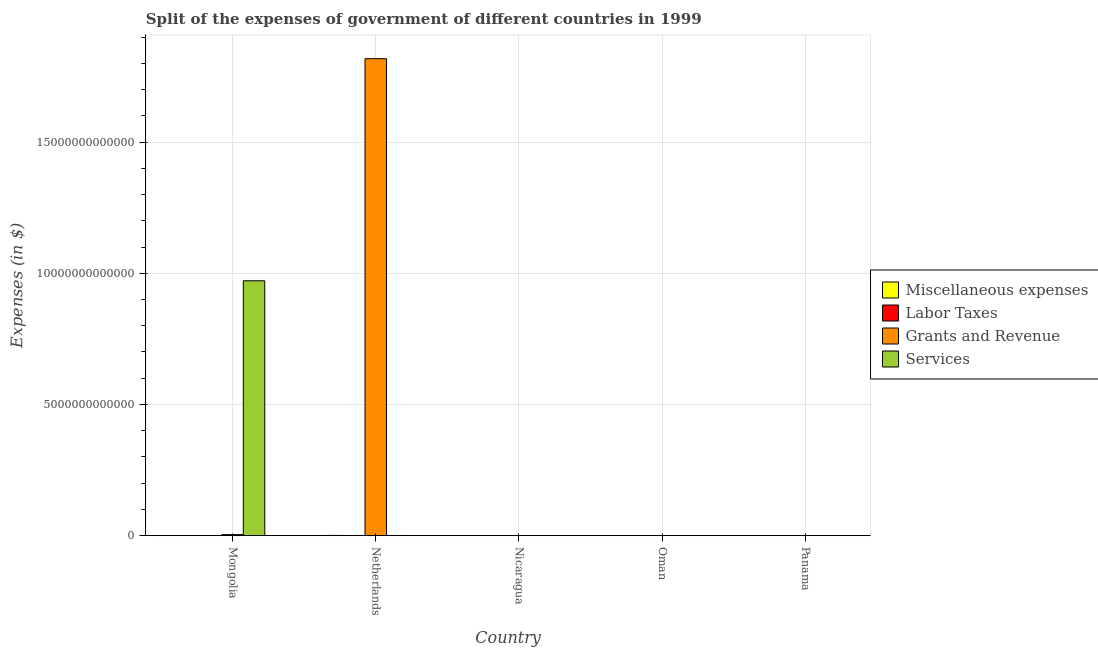How many different coloured bars are there?
Your answer should be compact. 4. How many groups of bars are there?
Provide a short and direct response. 5. Are the number of bars per tick equal to the number of legend labels?
Your response must be concise. No. How many bars are there on the 5th tick from the right?
Give a very brief answer. 4. What is the label of the 5th group of bars from the left?
Provide a short and direct response. Panama. What is the amount spent on grants and revenue in Panama?
Make the answer very short. 5.58e+08. Across all countries, what is the maximum amount spent on services?
Your answer should be compact. 9.71e+12. Across all countries, what is the minimum amount spent on labor taxes?
Ensure brevity in your answer.  0. In which country was the amount spent on labor taxes maximum?
Your answer should be compact. Oman. What is the total amount spent on labor taxes in the graph?
Make the answer very short. 1.25e+09. What is the difference between the amount spent on services in Mongolia and that in Panama?
Ensure brevity in your answer.  9.71e+12. What is the difference between the amount spent on services in Panama and the amount spent on miscellaneous expenses in Mongolia?
Your response must be concise. 3.16e+08. What is the average amount spent on miscellaneous expenses per country?
Provide a succinct answer. 1.67e+09. What is the difference between the amount spent on miscellaneous expenses and amount spent on services in Nicaragua?
Make the answer very short. 1.30e+09. What is the ratio of the amount spent on services in Mongolia to that in Oman?
Offer a very short reply. 2.63e+04. Is the difference between the amount spent on grants and revenue in Mongolia and Netherlands greater than the difference between the amount spent on miscellaneous expenses in Mongolia and Netherlands?
Make the answer very short. No. What is the difference between the highest and the second highest amount spent on labor taxes?
Your response must be concise. 4.94e+08. What is the difference between the highest and the lowest amount spent on grants and revenue?
Make the answer very short. 1.82e+13. Is the sum of the amount spent on services in Oman and Panama greater than the maximum amount spent on grants and revenue across all countries?
Provide a succinct answer. No. Is it the case that in every country, the sum of the amount spent on services and amount spent on miscellaneous expenses is greater than the sum of amount spent on labor taxes and amount spent on grants and revenue?
Make the answer very short. No. Is it the case that in every country, the sum of the amount spent on miscellaneous expenses and amount spent on labor taxes is greater than the amount spent on grants and revenue?
Your answer should be very brief. No. How many bars are there?
Your answer should be compact. 19. Are all the bars in the graph horizontal?
Your answer should be very brief. No. What is the difference between two consecutive major ticks on the Y-axis?
Give a very brief answer. 5.00e+12. Does the graph contain grids?
Offer a very short reply. Yes. Where does the legend appear in the graph?
Ensure brevity in your answer.  Center right. How many legend labels are there?
Offer a very short reply. 4. How are the legend labels stacked?
Offer a very short reply. Vertical. What is the title of the graph?
Provide a short and direct response. Split of the expenses of government of different countries in 1999. Does "Payroll services" appear as one of the legend labels in the graph?
Offer a terse response. No. What is the label or title of the X-axis?
Your answer should be compact. Country. What is the label or title of the Y-axis?
Your response must be concise. Expenses (in $). What is the Expenses (in $) in Miscellaneous expenses in Mongolia?
Your answer should be compact. 2.08e+09. What is the Expenses (in $) in Grants and Revenue in Mongolia?
Your answer should be very brief. 3.67e+1. What is the Expenses (in $) of Services in Mongolia?
Your answer should be compact. 9.71e+12. What is the Expenses (in $) in Miscellaneous expenses in Netherlands?
Offer a terse response. 4.78e+09. What is the Expenses (in $) in Labor Taxes in Netherlands?
Ensure brevity in your answer.  7.00e+05. What is the Expenses (in $) of Grants and Revenue in Netherlands?
Make the answer very short. 1.82e+13. What is the Expenses (in $) in Services in Netherlands?
Provide a succinct answer. 3.37e+09. What is the Expenses (in $) in Miscellaneous expenses in Nicaragua?
Your response must be concise. 1.48e+09. What is the Expenses (in $) of Labor Taxes in Nicaragua?
Your response must be concise. 3.77e+08. What is the Expenses (in $) of Grants and Revenue in Nicaragua?
Provide a short and direct response. 2.05e+09. What is the Expenses (in $) in Services in Nicaragua?
Keep it short and to the point. 1.86e+08. What is the Expenses (in $) of Miscellaneous expenses in Oman?
Keep it short and to the point. 1.80e+06. What is the Expenses (in $) in Labor Taxes in Oman?
Give a very brief answer. 8.71e+08. What is the Expenses (in $) in Grants and Revenue in Oman?
Your answer should be very brief. 1.65e+08. What is the Expenses (in $) of Services in Oman?
Your answer should be very brief. 3.69e+08. What is the Expenses (in $) of Miscellaneous expenses in Panama?
Offer a terse response. 1.29e+07. What is the Expenses (in $) of Grants and Revenue in Panama?
Offer a very short reply. 5.58e+08. What is the Expenses (in $) of Services in Panama?
Your answer should be compact. 2.40e+09. Across all countries, what is the maximum Expenses (in $) of Miscellaneous expenses?
Give a very brief answer. 4.78e+09. Across all countries, what is the maximum Expenses (in $) in Labor Taxes?
Provide a short and direct response. 8.71e+08. Across all countries, what is the maximum Expenses (in $) in Grants and Revenue?
Keep it short and to the point. 1.82e+13. Across all countries, what is the maximum Expenses (in $) in Services?
Your response must be concise. 9.71e+12. Across all countries, what is the minimum Expenses (in $) in Miscellaneous expenses?
Your answer should be very brief. 1.80e+06. Across all countries, what is the minimum Expenses (in $) of Labor Taxes?
Keep it short and to the point. 0. Across all countries, what is the minimum Expenses (in $) in Grants and Revenue?
Give a very brief answer. 1.65e+08. Across all countries, what is the minimum Expenses (in $) of Services?
Your response must be concise. 1.86e+08. What is the total Expenses (in $) in Miscellaneous expenses in the graph?
Offer a terse response. 8.36e+09. What is the total Expenses (in $) of Labor Taxes in the graph?
Your answer should be very brief. 1.25e+09. What is the total Expenses (in $) of Grants and Revenue in the graph?
Your response must be concise. 1.82e+13. What is the total Expenses (in $) of Services in the graph?
Give a very brief answer. 9.72e+12. What is the difference between the Expenses (in $) in Miscellaneous expenses in Mongolia and that in Netherlands?
Offer a very short reply. -2.69e+09. What is the difference between the Expenses (in $) in Labor Taxes in Mongolia and that in Netherlands?
Offer a very short reply. -6.00e+05. What is the difference between the Expenses (in $) in Grants and Revenue in Mongolia and that in Netherlands?
Your response must be concise. -1.81e+13. What is the difference between the Expenses (in $) of Services in Mongolia and that in Netherlands?
Make the answer very short. 9.71e+12. What is the difference between the Expenses (in $) in Miscellaneous expenses in Mongolia and that in Nicaragua?
Keep it short and to the point. 6.04e+08. What is the difference between the Expenses (in $) in Labor Taxes in Mongolia and that in Nicaragua?
Your answer should be very brief. -3.77e+08. What is the difference between the Expenses (in $) in Grants and Revenue in Mongolia and that in Nicaragua?
Your answer should be very brief. 3.46e+1. What is the difference between the Expenses (in $) of Services in Mongolia and that in Nicaragua?
Offer a terse response. 9.71e+12. What is the difference between the Expenses (in $) in Miscellaneous expenses in Mongolia and that in Oman?
Provide a succinct answer. 2.08e+09. What is the difference between the Expenses (in $) of Labor Taxes in Mongolia and that in Oman?
Provide a short and direct response. -8.71e+08. What is the difference between the Expenses (in $) of Grants and Revenue in Mongolia and that in Oman?
Your answer should be very brief. 3.65e+1. What is the difference between the Expenses (in $) in Services in Mongolia and that in Oman?
Make the answer very short. 9.71e+12. What is the difference between the Expenses (in $) in Miscellaneous expenses in Mongolia and that in Panama?
Your response must be concise. 2.07e+09. What is the difference between the Expenses (in $) of Grants and Revenue in Mongolia and that in Panama?
Provide a succinct answer. 3.61e+1. What is the difference between the Expenses (in $) in Services in Mongolia and that in Panama?
Offer a very short reply. 9.71e+12. What is the difference between the Expenses (in $) in Miscellaneous expenses in Netherlands and that in Nicaragua?
Your answer should be compact. 3.29e+09. What is the difference between the Expenses (in $) in Labor Taxes in Netherlands and that in Nicaragua?
Offer a very short reply. -3.76e+08. What is the difference between the Expenses (in $) of Grants and Revenue in Netherlands and that in Nicaragua?
Make the answer very short. 1.82e+13. What is the difference between the Expenses (in $) in Services in Netherlands and that in Nicaragua?
Keep it short and to the point. 3.18e+09. What is the difference between the Expenses (in $) in Miscellaneous expenses in Netherlands and that in Oman?
Offer a very short reply. 4.77e+09. What is the difference between the Expenses (in $) of Labor Taxes in Netherlands and that in Oman?
Ensure brevity in your answer.  -8.70e+08. What is the difference between the Expenses (in $) of Grants and Revenue in Netherlands and that in Oman?
Your answer should be very brief. 1.82e+13. What is the difference between the Expenses (in $) of Services in Netherlands and that in Oman?
Your answer should be compact. 3.00e+09. What is the difference between the Expenses (in $) of Miscellaneous expenses in Netherlands and that in Panama?
Offer a very short reply. 4.76e+09. What is the difference between the Expenses (in $) in Grants and Revenue in Netherlands and that in Panama?
Your answer should be very brief. 1.82e+13. What is the difference between the Expenses (in $) in Services in Netherlands and that in Panama?
Make the answer very short. 9.68e+08. What is the difference between the Expenses (in $) in Miscellaneous expenses in Nicaragua and that in Oman?
Ensure brevity in your answer.  1.48e+09. What is the difference between the Expenses (in $) of Labor Taxes in Nicaragua and that in Oman?
Keep it short and to the point. -4.94e+08. What is the difference between the Expenses (in $) of Grants and Revenue in Nicaragua and that in Oman?
Give a very brief answer. 1.89e+09. What is the difference between the Expenses (in $) in Services in Nicaragua and that in Oman?
Provide a succinct answer. -1.83e+08. What is the difference between the Expenses (in $) of Miscellaneous expenses in Nicaragua and that in Panama?
Your answer should be very brief. 1.47e+09. What is the difference between the Expenses (in $) of Grants and Revenue in Nicaragua and that in Panama?
Offer a very short reply. 1.49e+09. What is the difference between the Expenses (in $) of Services in Nicaragua and that in Panama?
Your answer should be compact. -2.22e+09. What is the difference between the Expenses (in $) of Miscellaneous expenses in Oman and that in Panama?
Your answer should be compact. -1.11e+07. What is the difference between the Expenses (in $) of Grants and Revenue in Oman and that in Panama?
Keep it short and to the point. -3.93e+08. What is the difference between the Expenses (in $) in Services in Oman and that in Panama?
Your response must be concise. -2.03e+09. What is the difference between the Expenses (in $) of Miscellaneous expenses in Mongolia and the Expenses (in $) of Labor Taxes in Netherlands?
Offer a very short reply. 2.08e+09. What is the difference between the Expenses (in $) of Miscellaneous expenses in Mongolia and the Expenses (in $) of Grants and Revenue in Netherlands?
Offer a terse response. -1.82e+13. What is the difference between the Expenses (in $) of Miscellaneous expenses in Mongolia and the Expenses (in $) of Services in Netherlands?
Give a very brief answer. -1.28e+09. What is the difference between the Expenses (in $) in Labor Taxes in Mongolia and the Expenses (in $) in Grants and Revenue in Netherlands?
Offer a very short reply. -1.82e+13. What is the difference between the Expenses (in $) in Labor Taxes in Mongolia and the Expenses (in $) in Services in Netherlands?
Your answer should be compact. -3.37e+09. What is the difference between the Expenses (in $) in Grants and Revenue in Mongolia and the Expenses (in $) in Services in Netherlands?
Keep it short and to the point. 3.33e+1. What is the difference between the Expenses (in $) in Miscellaneous expenses in Mongolia and the Expenses (in $) in Labor Taxes in Nicaragua?
Offer a very short reply. 1.71e+09. What is the difference between the Expenses (in $) in Miscellaneous expenses in Mongolia and the Expenses (in $) in Grants and Revenue in Nicaragua?
Make the answer very short. 3.50e+07. What is the difference between the Expenses (in $) of Miscellaneous expenses in Mongolia and the Expenses (in $) of Services in Nicaragua?
Make the answer very short. 1.90e+09. What is the difference between the Expenses (in $) in Labor Taxes in Mongolia and the Expenses (in $) in Grants and Revenue in Nicaragua?
Offer a terse response. -2.05e+09. What is the difference between the Expenses (in $) in Labor Taxes in Mongolia and the Expenses (in $) in Services in Nicaragua?
Offer a terse response. -1.86e+08. What is the difference between the Expenses (in $) of Grants and Revenue in Mongolia and the Expenses (in $) of Services in Nicaragua?
Offer a very short reply. 3.65e+1. What is the difference between the Expenses (in $) in Miscellaneous expenses in Mongolia and the Expenses (in $) in Labor Taxes in Oman?
Give a very brief answer. 1.21e+09. What is the difference between the Expenses (in $) of Miscellaneous expenses in Mongolia and the Expenses (in $) of Grants and Revenue in Oman?
Your answer should be very brief. 1.92e+09. What is the difference between the Expenses (in $) in Miscellaneous expenses in Mongolia and the Expenses (in $) in Services in Oman?
Provide a short and direct response. 1.72e+09. What is the difference between the Expenses (in $) of Labor Taxes in Mongolia and the Expenses (in $) of Grants and Revenue in Oman?
Provide a short and direct response. -1.65e+08. What is the difference between the Expenses (in $) of Labor Taxes in Mongolia and the Expenses (in $) of Services in Oman?
Offer a terse response. -3.69e+08. What is the difference between the Expenses (in $) of Grants and Revenue in Mongolia and the Expenses (in $) of Services in Oman?
Your answer should be compact. 3.63e+1. What is the difference between the Expenses (in $) in Miscellaneous expenses in Mongolia and the Expenses (in $) in Grants and Revenue in Panama?
Your answer should be compact. 1.53e+09. What is the difference between the Expenses (in $) in Miscellaneous expenses in Mongolia and the Expenses (in $) in Services in Panama?
Your answer should be compact. -3.16e+08. What is the difference between the Expenses (in $) of Labor Taxes in Mongolia and the Expenses (in $) of Grants and Revenue in Panama?
Your answer should be compact. -5.58e+08. What is the difference between the Expenses (in $) of Labor Taxes in Mongolia and the Expenses (in $) of Services in Panama?
Offer a terse response. -2.40e+09. What is the difference between the Expenses (in $) in Grants and Revenue in Mongolia and the Expenses (in $) in Services in Panama?
Give a very brief answer. 3.43e+1. What is the difference between the Expenses (in $) in Miscellaneous expenses in Netherlands and the Expenses (in $) in Labor Taxes in Nicaragua?
Your answer should be very brief. 4.40e+09. What is the difference between the Expenses (in $) in Miscellaneous expenses in Netherlands and the Expenses (in $) in Grants and Revenue in Nicaragua?
Give a very brief answer. 2.73e+09. What is the difference between the Expenses (in $) in Miscellaneous expenses in Netherlands and the Expenses (in $) in Services in Nicaragua?
Offer a very short reply. 4.59e+09. What is the difference between the Expenses (in $) of Labor Taxes in Netherlands and the Expenses (in $) of Grants and Revenue in Nicaragua?
Give a very brief answer. -2.05e+09. What is the difference between the Expenses (in $) in Labor Taxes in Netherlands and the Expenses (in $) in Services in Nicaragua?
Make the answer very short. -1.85e+08. What is the difference between the Expenses (in $) of Grants and Revenue in Netherlands and the Expenses (in $) of Services in Nicaragua?
Your response must be concise. 1.82e+13. What is the difference between the Expenses (in $) of Miscellaneous expenses in Netherlands and the Expenses (in $) of Labor Taxes in Oman?
Ensure brevity in your answer.  3.90e+09. What is the difference between the Expenses (in $) in Miscellaneous expenses in Netherlands and the Expenses (in $) in Grants and Revenue in Oman?
Offer a terse response. 4.61e+09. What is the difference between the Expenses (in $) of Miscellaneous expenses in Netherlands and the Expenses (in $) of Services in Oman?
Ensure brevity in your answer.  4.41e+09. What is the difference between the Expenses (in $) in Labor Taxes in Netherlands and the Expenses (in $) in Grants and Revenue in Oman?
Ensure brevity in your answer.  -1.64e+08. What is the difference between the Expenses (in $) in Labor Taxes in Netherlands and the Expenses (in $) in Services in Oman?
Your answer should be very brief. -3.68e+08. What is the difference between the Expenses (in $) of Grants and Revenue in Netherlands and the Expenses (in $) of Services in Oman?
Offer a terse response. 1.82e+13. What is the difference between the Expenses (in $) in Miscellaneous expenses in Netherlands and the Expenses (in $) in Grants and Revenue in Panama?
Offer a very short reply. 4.22e+09. What is the difference between the Expenses (in $) of Miscellaneous expenses in Netherlands and the Expenses (in $) of Services in Panama?
Your answer should be very brief. 2.38e+09. What is the difference between the Expenses (in $) in Labor Taxes in Netherlands and the Expenses (in $) in Grants and Revenue in Panama?
Keep it short and to the point. -5.57e+08. What is the difference between the Expenses (in $) in Labor Taxes in Netherlands and the Expenses (in $) in Services in Panama?
Offer a very short reply. -2.40e+09. What is the difference between the Expenses (in $) in Grants and Revenue in Netherlands and the Expenses (in $) in Services in Panama?
Your answer should be compact. 1.82e+13. What is the difference between the Expenses (in $) of Miscellaneous expenses in Nicaragua and the Expenses (in $) of Labor Taxes in Oman?
Provide a succinct answer. 6.10e+08. What is the difference between the Expenses (in $) in Miscellaneous expenses in Nicaragua and the Expenses (in $) in Grants and Revenue in Oman?
Offer a very short reply. 1.32e+09. What is the difference between the Expenses (in $) in Miscellaneous expenses in Nicaragua and the Expenses (in $) in Services in Oman?
Offer a terse response. 1.11e+09. What is the difference between the Expenses (in $) of Labor Taxes in Nicaragua and the Expenses (in $) of Grants and Revenue in Oman?
Offer a very short reply. 2.12e+08. What is the difference between the Expenses (in $) in Labor Taxes in Nicaragua and the Expenses (in $) in Services in Oman?
Your answer should be very brief. 7.75e+06. What is the difference between the Expenses (in $) in Grants and Revenue in Nicaragua and the Expenses (in $) in Services in Oman?
Make the answer very short. 1.68e+09. What is the difference between the Expenses (in $) of Miscellaneous expenses in Nicaragua and the Expenses (in $) of Grants and Revenue in Panama?
Your answer should be very brief. 9.24e+08. What is the difference between the Expenses (in $) in Miscellaneous expenses in Nicaragua and the Expenses (in $) in Services in Panama?
Make the answer very short. -9.20e+08. What is the difference between the Expenses (in $) of Labor Taxes in Nicaragua and the Expenses (in $) of Grants and Revenue in Panama?
Your answer should be compact. -1.81e+08. What is the difference between the Expenses (in $) in Labor Taxes in Nicaragua and the Expenses (in $) in Services in Panama?
Your answer should be compact. -2.02e+09. What is the difference between the Expenses (in $) in Grants and Revenue in Nicaragua and the Expenses (in $) in Services in Panama?
Your answer should be compact. -3.51e+08. What is the difference between the Expenses (in $) in Miscellaneous expenses in Oman and the Expenses (in $) in Grants and Revenue in Panama?
Keep it short and to the point. -5.56e+08. What is the difference between the Expenses (in $) in Miscellaneous expenses in Oman and the Expenses (in $) in Services in Panama?
Your answer should be compact. -2.40e+09. What is the difference between the Expenses (in $) of Labor Taxes in Oman and the Expenses (in $) of Grants and Revenue in Panama?
Keep it short and to the point. 3.13e+08. What is the difference between the Expenses (in $) of Labor Taxes in Oman and the Expenses (in $) of Services in Panama?
Your answer should be compact. -1.53e+09. What is the difference between the Expenses (in $) in Grants and Revenue in Oman and the Expenses (in $) in Services in Panama?
Your answer should be very brief. -2.24e+09. What is the average Expenses (in $) of Miscellaneous expenses per country?
Provide a short and direct response. 1.67e+09. What is the average Expenses (in $) in Labor Taxes per country?
Give a very brief answer. 2.50e+08. What is the average Expenses (in $) of Grants and Revenue per country?
Ensure brevity in your answer.  3.64e+12. What is the average Expenses (in $) in Services per country?
Give a very brief answer. 1.94e+12. What is the difference between the Expenses (in $) in Miscellaneous expenses and Expenses (in $) in Labor Taxes in Mongolia?
Your answer should be compact. 2.08e+09. What is the difference between the Expenses (in $) in Miscellaneous expenses and Expenses (in $) in Grants and Revenue in Mongolia?
Your answer should be compact. -3.46e+1. What is the difference between the Expenses (in $) of Miscellaneous expenses and Expenses (in $) of Services in Mongolia?
Provide a short and direct response. -9.71e+12. What is the difference between the Expenses (in $) in Labor Taxes and Expenses (in $) in Grants and Revenue in Mongolia?
Keep it short and to the point. -3.67e+1. What is the difference between the Expenses (in $) of Labor Taxes and Expenses (in $) of Services in Mongolia?
Keep it short and to the point. -9.71e+12. What is the difference between the Expenses (in $) in Grants and Revenue and Expenses (in $) in Services in Mongolia?
Your answer should be very brief. -9.68e+12. What is the difference between the Expenses (in $) of Miscellaneous expenses and Expenses (in $) of Labor Taxes in Netherlands?
Provide a short and direct response. 4.78e+09. What is the difference between the Expenses (in $) in Miscellaneous expenses and Expenses (in $) in Grants and Revenue in Netherlands?
Offer a terse response. -1.82e+13. What is the difference between the Expenses (in $) of Miscellaneous expenses and Expenses (in $) of Services in Netherlands?
Ensure brevity in your answer.  1.41e+09. What is the difference between the Expenses (in $) in Labor Taxes and Expenses (in $) in Grants and Revenue in Netherlands?
Your answer should be compact. -1.82e+13. What is the difference between the Expenses (in $) in Labor Taxes and Expenses (in $) in Services in Netherlands?
Your response must be concise. -3.37e+09. What is the difference between the Expenses (in $) of Grants and Revenue and Expenses (in $) of Services in Netherlands?
Provide a succinct answer. 1.82e+13. What is the difference between the Expenses (in $) in Miscellaneous expenses and Expenses (in $) in Labor Taxes in Nicaragua?
Ensure brevity in your answer.  1.10e+09. What is the difference between the Expenses (in $) in Miscellaneous expenses and Expenses (in $) in Grants and Revenue in Nicaragua?
Provide a succinct answer. -5.69e+08. What is the difference between the Expenses (in $) of Miscellaneous expenses and Expenses (in $) of Services in Nicaragua?
Make the answer very short. 1.30e+09. What is the difference between the Expenses (in $) of Labor Taxes and Expenses (in $) of Grants and Revenue in Nicaragua?
Provide a succinct answer. -1.67e+09. What is the difference between the Expenses (in $) in Labor Taxes and Expenses (in $) in Services in Nicaragua?
Offer a very short reply. 1.91e+08. What is the difference between the Expenses (in $) of Grants and Revenue and Expenses (in $) of Services in Nicaragua?
Keep it short and to the point. 1.86e+09. What is the difference between the Expenses (in $) in Miscellaneous expenses and Expenses (in $) in Labor Taxes in Oman?
Make the answer very short. -8.69e+08. What is the difference between the Expenses (in $) in Miscellaneous expenses and Expenses (in $) in Grants and Revenue in Oman?
Your response must be concise. -1.63e+08. What is the difference between the Expenses (in $) of Miscellaneous expenses and Expenses (in $) of Services in Oman?
Keep it short and to the point. -3.67e+08. What is the difference between the Expenses (in $) of Labor Taxes and Expenses (in $) of Grants and Revenue in Oman?
Provide a succinct answer. 7.06e+08. What is the difference between the Expenses (in $) in Labor Taxes and Expenses (in $) in Services in Oman?
Provide a succinct answer. 5.02e+08. What is the difference between the Expenses (in $) of Grants and Revenue and Expenses (in $) of Services in Oman?
Offer a terse response. -2.04e+08. What is the difference between the Expenses (in $) in Miscellaneous expenses and Expenses (in $) in Grants and Revenue in Panama?
Your answer should be very brief. -5.45e+08. What is the difference between the Expenses (in $) of Miscellaneous expenses and Expenses (in $) of Services in Panama?
Make the answer very short. -2.39e+09. What is the difference between the Expenses (in $) of Grants and Revenue and Expenses (in $) of Services in Panama?
Offer a terse response. -1.84e+09. What is the ratio of the Expenses (in $) of Miscellaneous expenses in Mongolia to that in Netherlands?
Provide a short and direct response. 0.44. What is the ratio of the Expenses (in $) of Labor Taxes in Mongolia to that in Netherlands?
Your answer should be compact. 0.14. What is the ratio of the Expenses (in $) in Grants and Revenue in Mongolia to that in Netherlands?
Your answer should be very brief. 0. What is the ratio of the Expenses (in $) in Services in Mongolia to that in Netherlands?
Give a very brief answer. 2883.79. What is the ratio of the Expenses (in $) of Miscellaneous expenses in Mongolia to that in Nicaragua?
Provide a succinct answer. 1.41. What is the ratio of the Expenses (in $) of Grants and Revenue in Mongolia to that in Nicaragua?
Offer a very short reply. 17.88. What is the ratio of the Expenses (in $) in Services in Mongolia to that in Nicaragua?
Provide a succinct answer. 5.22e+04. What is the ratio of the Expenses (in $) of Miscellaneous expenses in Mongolia to that in Oman?
Your response must be concise. 1158.33. What is the ratio of the Expenses (in $) of Labor Taxes in Mongolia to that in Oman?
Provide a short and direct response. 0. What is the ratio of the Expenses (in $) in Grants and Revenue in Mongolia to that in Oman?
Give a very brief answer. 222.63. What is the ratio of the Expenses (in $) of Services in Mongolia to that in Oman?
Ensure brevity in your answer.  2.63e+04. What is the ratio of the Expenses (in $) of Miscellaneous expenses in Mongolia to that in Panama?
Offer a very short reply. 161.63. What is the ratio of the Expenses (in $) of Grants and Revenue in Mongolia to that in Panama?
Provide a short and direct response. 65.72. What is the ratio of the Expenses (in $) in Services in Mongolia to that in Panama?
Ensure brevity in your answer.  4046.01. What is the ratio of the Expenses (in $) in Miscellaneous expenses in Netherlands to that in Nicaragua?
Your answer should be very brief. 3.22. What is the ratio of the Expenses (in $) of Labor Taxes in Netherlands to that in Nicaragua?
Your answer should be very brief. 0. What is the ratio of the Expenses (in $) of Grants and Revenue in Netherlands to that in Nicaragua?
Provide a short and direct response. 8868.21. What is the ratio of the Expenses (in $) in Services in Netherlands to that in Nicaragua?
Keep it short and to the point. 18.11. What is the ratio of the Expenses (in $) of Miscellaneous expenses in Netherlands to that in Oman?
Provide a succinct answer. 2653.33. What is the ratio of the Expenses (in $) of Labor Taxes in Netherlands to that in Oman?
Provide a succinct answer. 0. What is the ratio of the Expenses (in $) in Grants and Revenue in Netherlands to that in Oman?
Make the answer very short. 1.10e+05. What is the ratio of the Expenses (in $) in Services in Netherlands to that in Oman?
Make the answer very short. 9.13. What is the ratio of the Expenses (in $) of Miscellaneous expenses in Netherlands to that in Panama?
Offer a very short reply. 370.23. What is the ratio of the Expenses (in $) of Grants and Revenue in Netherlands to that in Panama?
Your answer should be very brief. 3.26e+04. What is the ratio of the Expenses (in $) in Services in Netherlands to that in Panama?
Offer a terse response. 1.4. What is the ratio of the Expenses (in $) in Miscellaneous expenses in Nicaragua to that in Oman?
Keep it short and to the point. 823.03. What is the ratio of the Expenses (in $) of Labor Taxes in Nicaragua to that in Oman?
Offer a terse response. 0.43. What is the ratio of the Expenses (in $) of Grants and Revenue in Nicaragua to that in Oman?
Provide a succinct answer. 12.45. What is the ratio of the Expenses (in $) in Services in Nicaragua to that in Oman?
Provide a succinct answer. 0.5. What is the ratio of the Expenses (in $) in Miscellaneous expenses in Nicaragua to that in Panama?
Provide a short and direct response. 114.84. What is the ratio of the Expenses (in $) in Grants and Revenue in Nicaragua to that in Panama?
Your response must be concise. 3.68. What is the ratio of the Expenses (in $) in Services in Nicaragua to that in Panama?
Provide a succinct answer. 0.08. What is the ratio of the Expenses (in $) in Miscellaneous expenses in Oman to that in Panama?
Keep it short and to the point. 0.14. What is the ratio of the Expenses (in $) of Grants and Revenue in Oman to that in Panama?
Your response must be concise. 0.3. What is the ratio of the Expenses (in $) of Services in Oman to that in Panama?
Keep it short and to the point. 0.15. What is the difference between the highest and the second highest Expenses (in $) of Miscellaneous expenses?
Offer a very short reply. 2.69e+09. What is the difference between the highest and the second highest Expenses (in $) in Labor Taxes?
Give a very brief answer. 4.94e+08. What is the difference between the highest and the second highest Expenses (in $) in Grants and Revenue?
Ensure brevity in your answer.  1.81e+13. What is the difference between the highest and the second highest Expenses (in $) in Services?
Make the answer very short. 9.71e+12. What is the difference between the highest and the lowest Expenses (in $) of Miscellaneous expenses?
Provide a short and direct response. 4.77e+09. What is the difference between the highest and the lowest Expenses (in $) of Labor Taxes?
Your answer should be compact. 8.71e+08. What is the difference between the highest and the lowest Expenses (in $) in Grants and Revenue?
Your answer should be very brief. 1.82e+13. What is the difference between the highest and the lowest Expenses (in $) in Services?
Make the answer very short. 9.71e+12. 